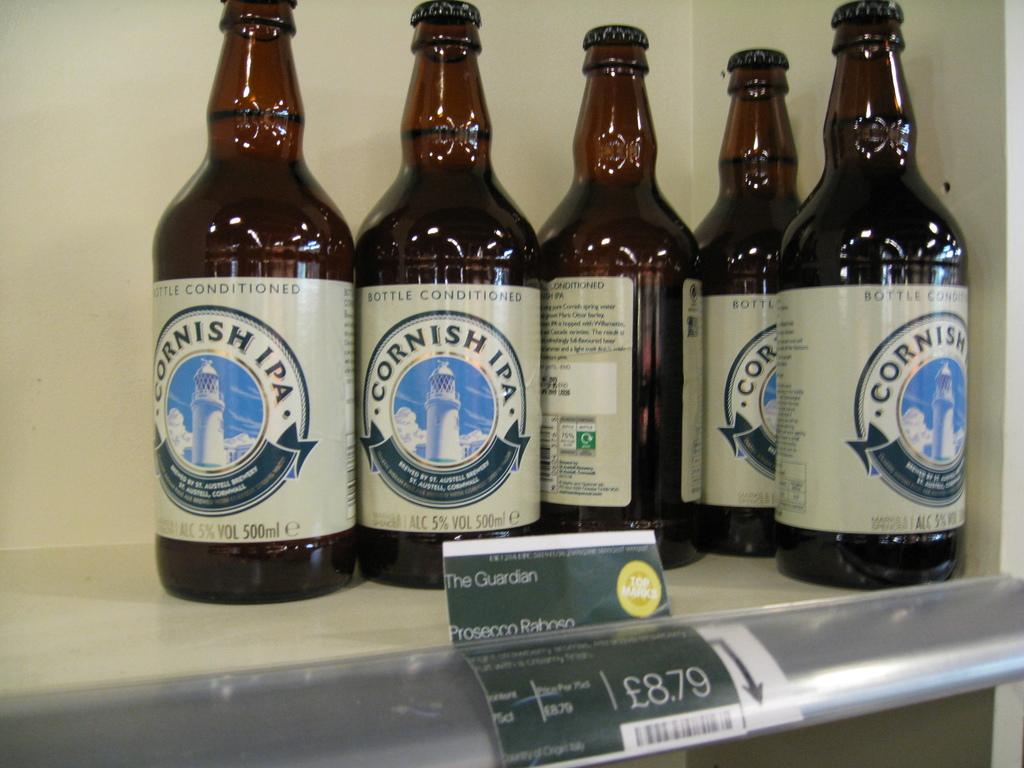What kind of beer is this?
Make the answer very short. Cornish ipa. What is the price of the beer?
Your answer should be compact. 8.79. 